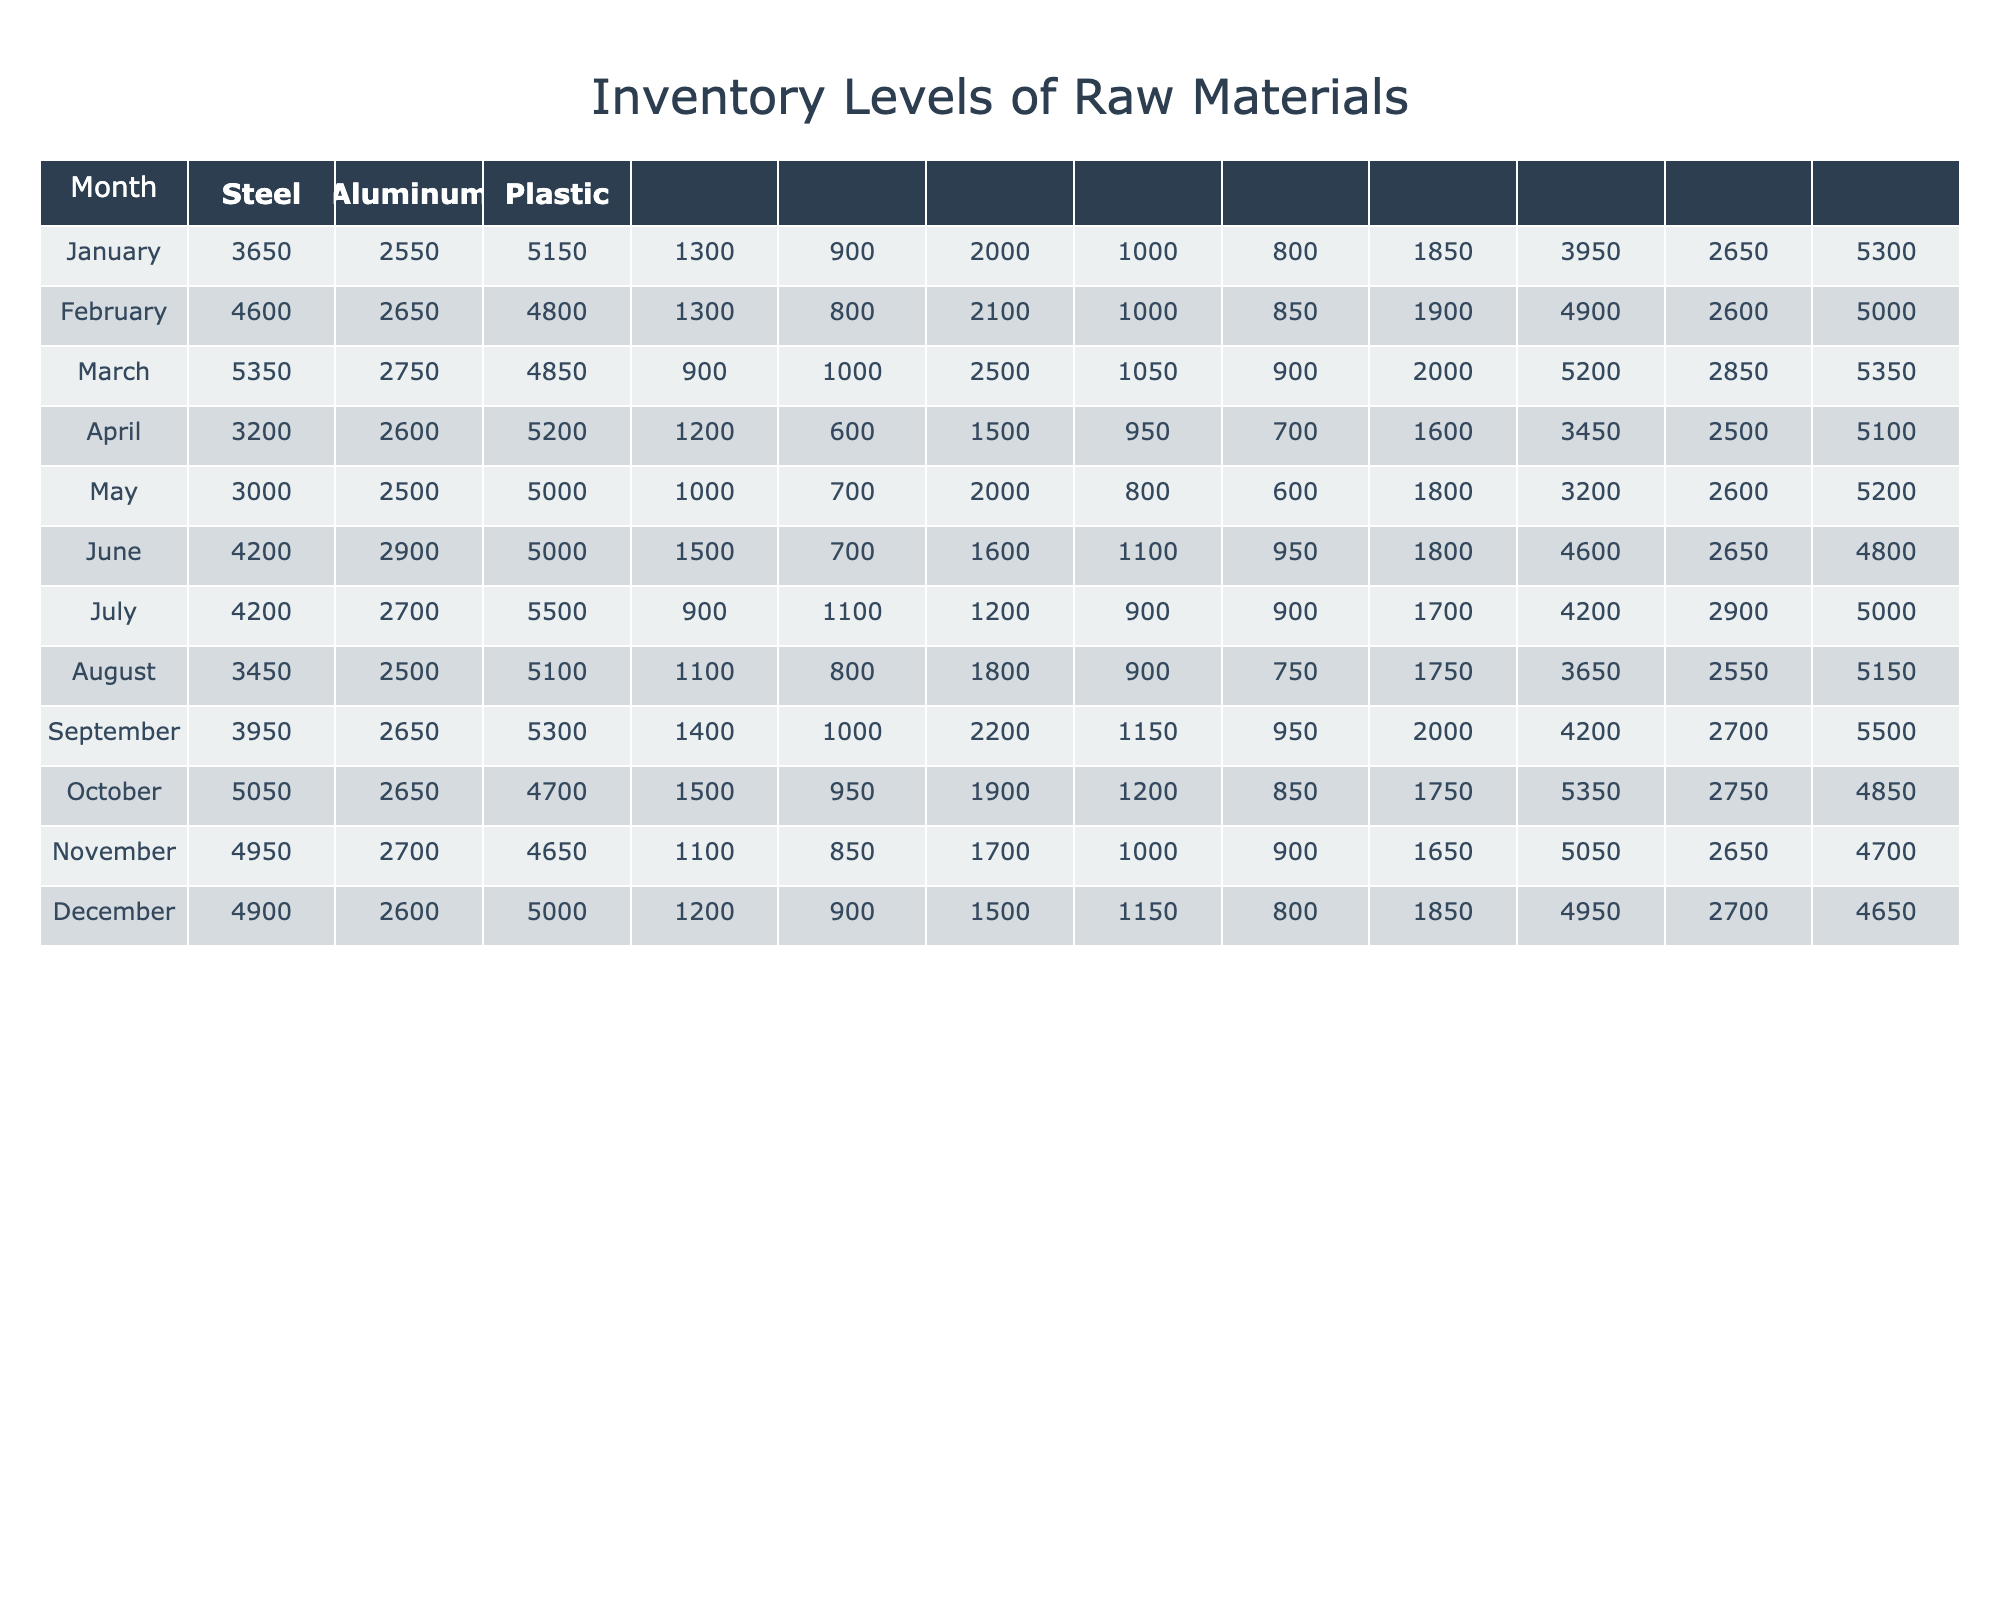What was the ending inventory of Steel in March? The table shows that the ending inventory for Steel in March is listed directly under the March row for Steel. By checking the corresponding value, we find that the ending inventory is 5150.
Answer: 5150 What is the total amount of Aluminum received over the entire year? To find the total amount of Aluminum received, we need to sum the amounts received each month. The monthly received values are 1000, 1200, 1100, 1300, 1400, 900, 1500, 1300, 1200, 1100, 1500, and 900. Adding these amounts gives us a total of: 1000 + 1200 + 1100 + 1300 + 1400 + 900 + 1500 + 1300 + 1200 + 1100 + 1500 + 900 = 15200.
Answer: 15200 Is the ending inventory of Plastic in December greater than its starting inventory in January? In December, the ending inventory for Plastic is 2850, while the starting inventory in January is 2500. Since 2850 is greater than 2500, the answer is yes.
Answer: Yes What is the difference between the ending inventory of Steel in May and Aluminum in May? The ending inventory of Steel in May is 5500, and for Aluminum, it is 4200. The difference can be calculated as follows: 5500 - 4200 = 1300.
Answer: 1300 Which month had the highest consumption of Steel? To determine which month had the highest consumption of Steel, we examine the consumed values for each month: January (1800), February (1600), March (1750), April (1850), May (2000), June (1700), July (1800), August (1900), September (1850), October (1650), November (1750), December (2000). The highest consumption is 2000 in both May and December.
Answer: May and December What is the average ending inventory of Aluminum over the year? First, we find the ending inventory values for Aluminum each month: 3200, 3450, 3650, 3950, 4200, 4200, 4600, 4900, 4950, 5050, 5350, 5200. Summing these values gives us: 3200 + 3450 + 3650 + 3950 + 4200 + 4200 + 4600 + 4900 + 4950 + 5050 + 5350 + 5200 = 50500. There are 12 months, so we divide by 12: 50500 / 12 = 4208.33.
Answer: 4208.33 Was the starting inventory of Plastic in February lower than the ending inventory of Steel in February? The starting inventory of Plastic in February is 2600, while the ending inventory of Steel in February is 5100. Since 2600 is lower than 5100, the answer is yes.
Answer: Yes Which month had the lowest ending inventory of Steel? The ending inventory of Steel for each month is: January (5200), February (5100), March (5150), April (5300), May (5500), June (5000), July (4800), August (5000), September (4650), October (4700), November (4850), December (5350). The lowest ending inventory is 4650 in September.
Answer: September 